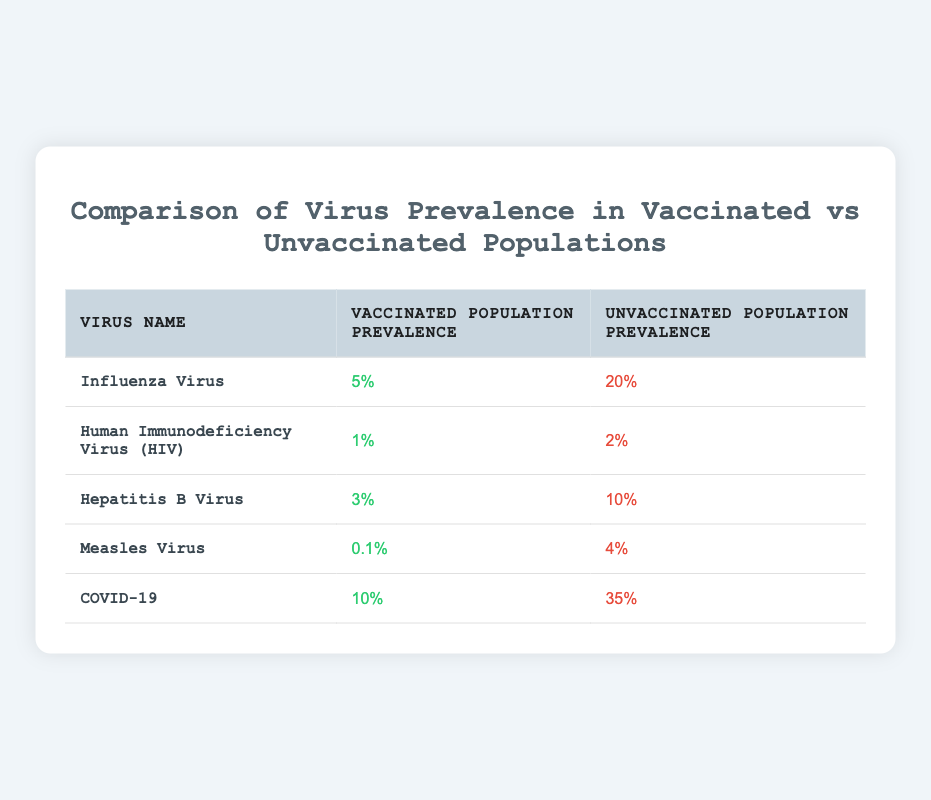What is the prevalence of Influenza Virus in the vaccinated population? The table shows that the prevalence of Influenza Virus in the vaccinated population is listed as 5%.
Answer: 5% What is the difference in prevalence between vaccinated and unvaccinated populations for Hepatitis B Virus? For Hepatitis B Virus, the prevalence in the vaccinated population is 3% and the prevalence in the unvaccinated population is 10%. The difference is calculated as 10% - 3% = 7%.
Answer: 7% Is the prevalence of COVID-19 higher in the vaccinated or unvaccinated population? The prevalence of COVID-19 in the vaccinated population is 10% and in the unvaccinated population is 35%. Since 35% is greater than 10%, the prevalence is higher in the unvaccinated population.
Answer: Yes Which virus has the lowest prevalence in the vaccinated population? Reviewing the table, the prevalence values for the vaccinated populations are: Influenza (5%), HIV (1%), Hepatitis B (3%), Measles (0.1%), and COVID-19 (10%). The lowest prevalence is for Measles at 0.1%.
Answer: Measles Virus What is the average prevalence of the viruses in the unvaccinated population? The unvaccinated population prevalences are 20% (Influenza), 2% (HIV), 10% (Hepatitis B), 4% (Measles), and 35% (COVID-19). Adding these together gives 20 + 2 + 10 + 4 + 35 = 71%. There are 5 viruses, so the average prevalence is 71% / 5 = 14.2%.
Answer: 14.2% 